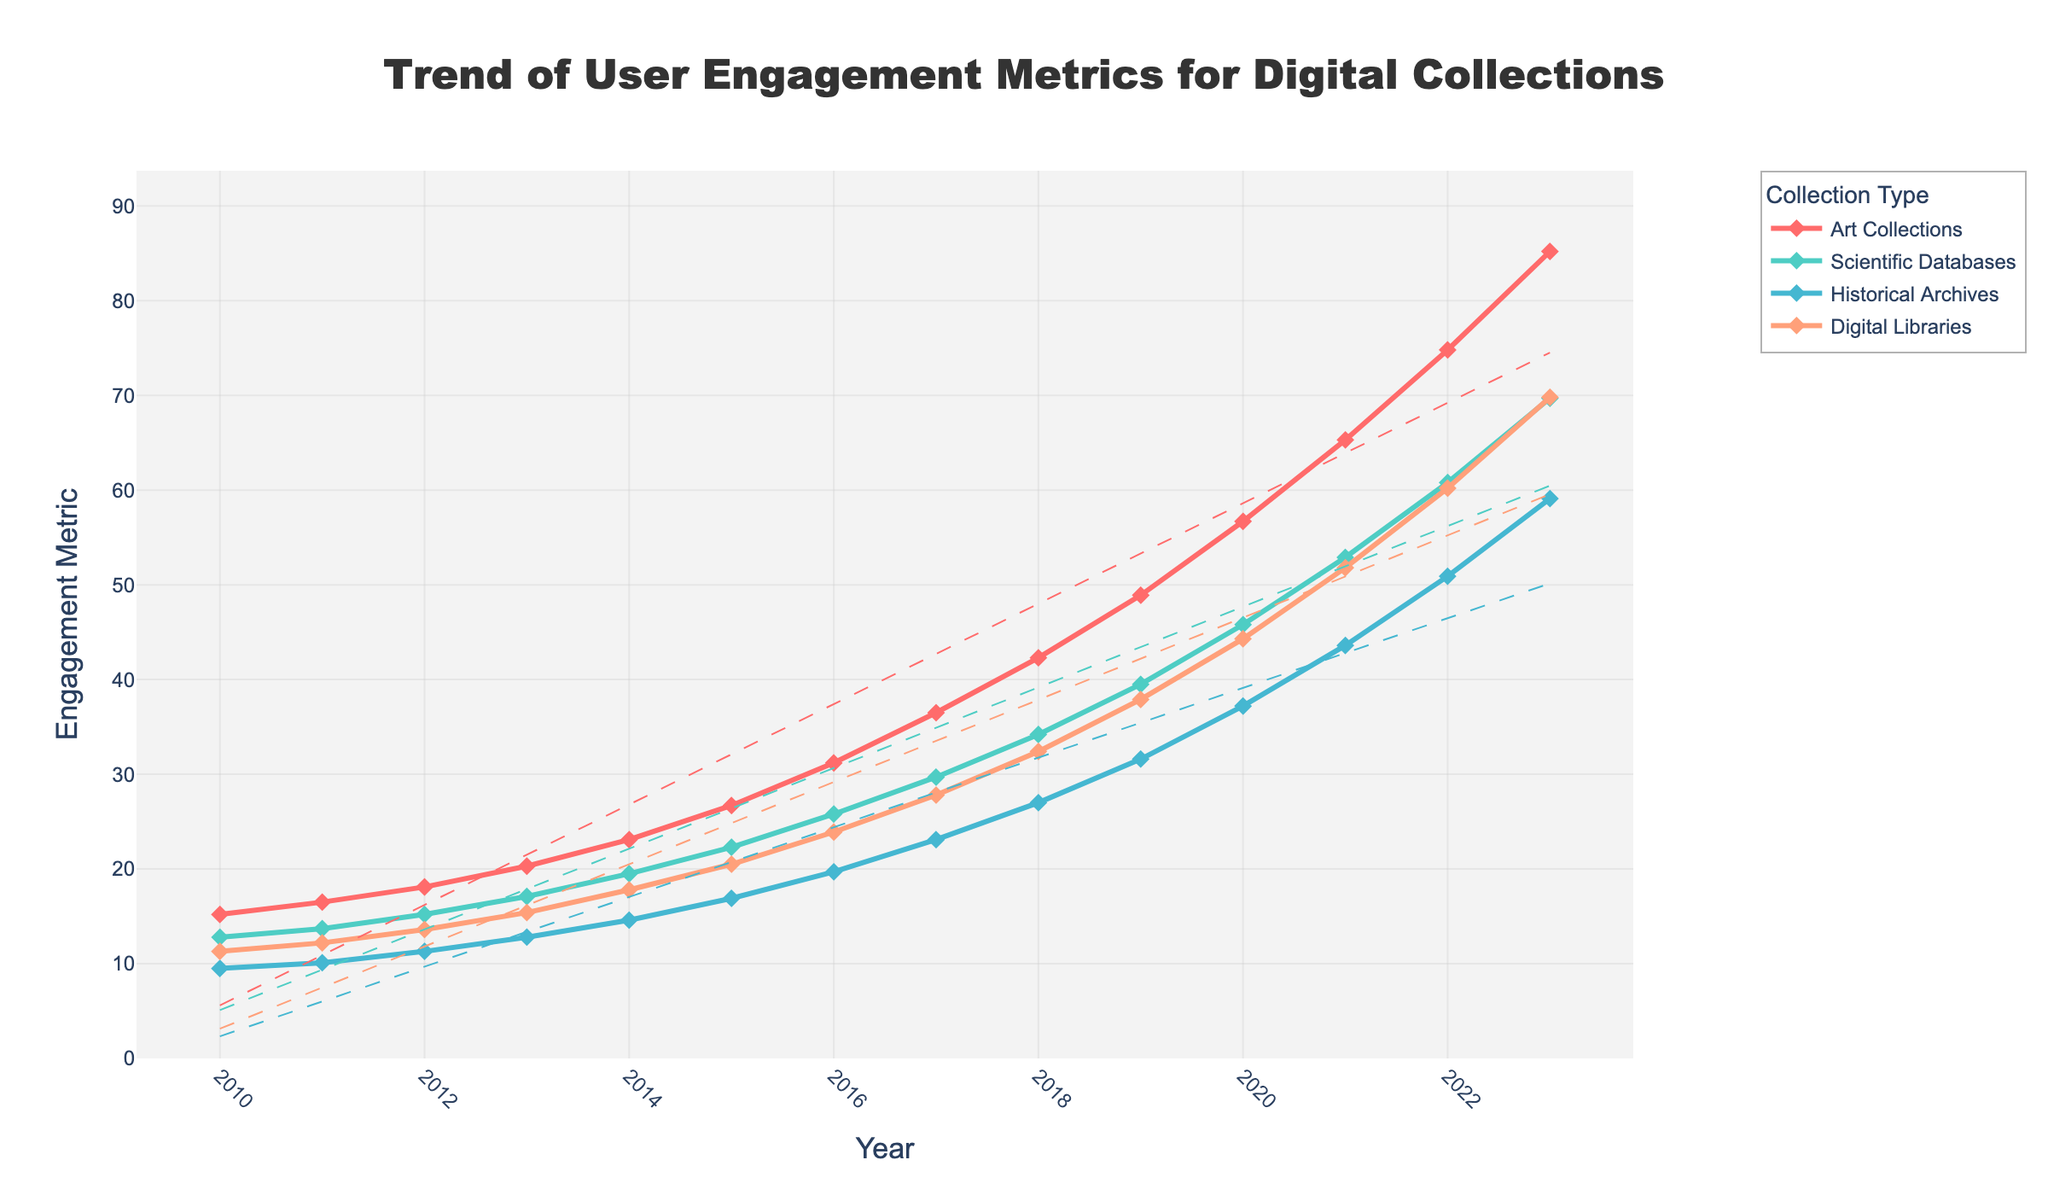What is the overall trend for user engagement in Art Collections from 2010 to 2023? The line representing Art Collections shows a consistent upward trajectory from 15.2 in 2010 to 85.2 in 2023, indicating increased user engagement over time.
Answer: Upward trend Which collection type had the highest engagement metric in 2023, and what was the value? Looking at the year 2023, the line for Art Collections is the highest, reaching 85.2.
Answer: Art Collections, 85.2 How do the engagement metrics in 2015 compare between Scientific Databases and Historical Archives? Referencing the year 2015, Scientific Databases have an engagement metric of 22.3, while Historical Archives have 16.9. Therefore, Scientific Databases had higher engagement.
Answer: Scientific Databases higher, 22.3 vs 16.9 Between which consecutive years did the Art Collections see the largest increase in user engagement? By examining the year-over-year differences, the largest increase for Art Collections occurred between 2022 (74.8) and 2023 (85.2), which is an increase of 10.4.
Answer: Between 2022 and 2023 What is the average user engagement for Digital Libraries over the years provided? Sum the engagement values for Digital Libraries from 2010 to 2023 and divide by the number of years: (11.3 + 12.2 + 13.6 + 15.4 + 17.8 + 20.5 + 23.9 + 27.8 + 32.4 + 37.9 + 44.3 + 51.8 + 60.2 + 69.8) / 14 = 33.3
Answer: 33.3 What color represents the Historical Archives in the figure? The color corresponding to the Historical Archives line is a visual attribute in the chart, identified as blue.
Answer: Blue Which collection type shows the least variability in user engagement over the years? By looking at the slopes and the extent of fluctuations for each line, Historical Archives show the least variability in user engagement, as evidenced by its smoother and less steep increments.
Answer: Historical Archives What is the average yearly increase in engagement for Scientific Databases from 2010 to 2023? Calculate the total increase (69.7 - 12.8 = 56.9) and divide by the number of years (2023 - 2010 = 13): 56.9 / 13 = approximately 4.38 per year.
Answer: 4.38 per year 